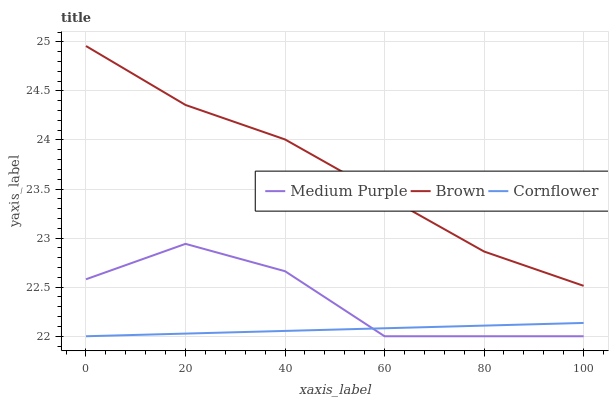Does Cornflower have the minimum area under the curve?
Answer yes or no. Yes. Does Brown have the maximum area under the curve?
Answer yes or no. Yes. Does Brown have the minimum area under the curve?
Answer yes or no. No. Does Cornflower have the maximum area under the curve?
Answer yes or no. No. Is Cornflower the smoothest?
Answer yes or no. Yes. Is Medium Purple the roughest?
Answer yes or no. Yes. Is Brown the smoothest?
Answer yes or no. No. Is Brown the roughest?
Answer yes or no. No. Does Medium Purple have the lowest value?
Answer yes or no. Yes. Does Brown have the lowest value?
Answer yes or no. No. Does Brown have the highest value?
Answer yes or no. Yes. Does Cornflower have the highest value?
Answer yes or no. No. Is Medium Purple less than Brown?
Answer yes or no. Yes. Is Brown greater than Medium Purple?
Answer yes or no. Yes. Does Medium Purple intersect Cornflower?
Answer yes or no. Yes. Is Medium Purple less than Cornflower?
Answer yes or no. No. Is Medium Purple greater than Cornflower?
Answer yes or no. No. Does Medium Purple intersect Brown?
Answer yes or no. No. 